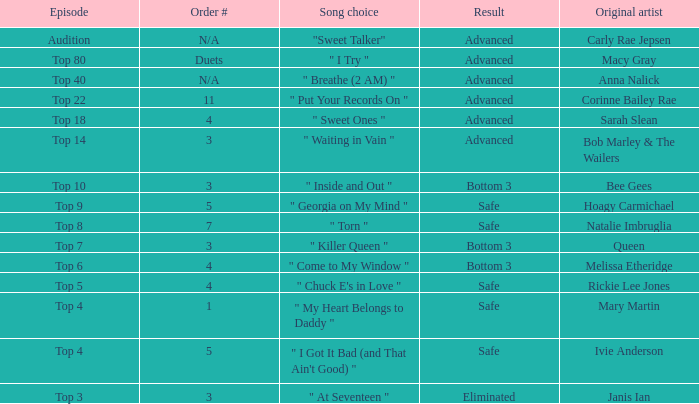What's the original artist of the song performed in the top 3 episode? Janis Ian. 